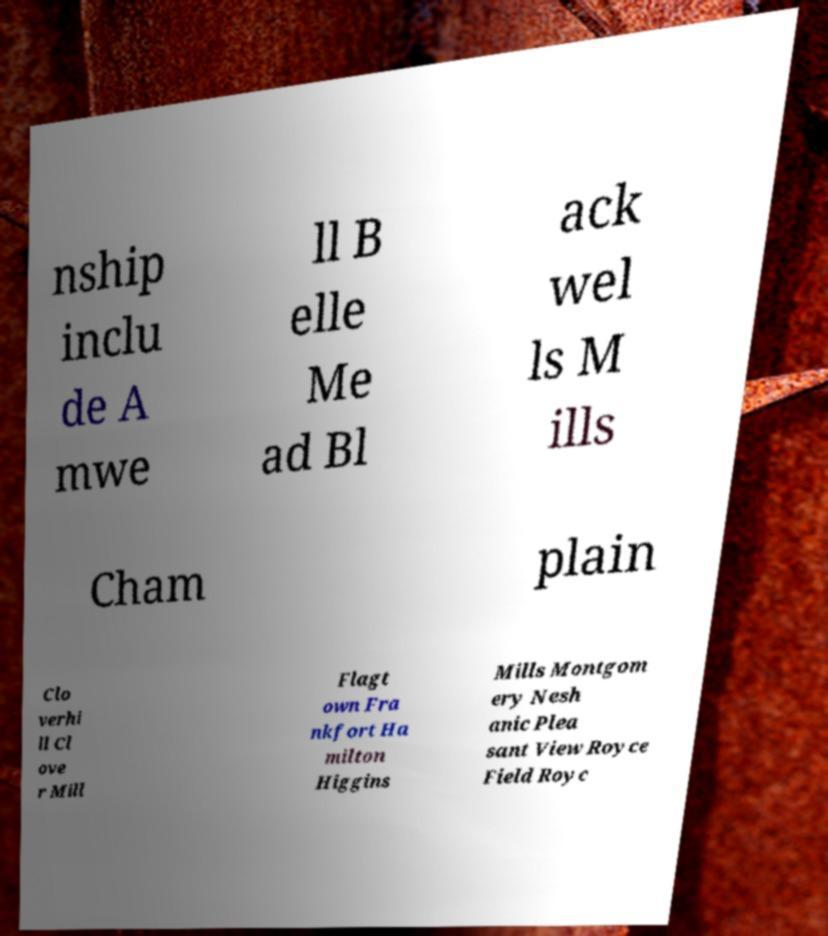Can you accurately transcribe the text from the provided image for me? nship inclu de A mwe ll B elle Me ad Bl ack wel ls M ills Cham plain Clo verhi ll Cl ove r Mill Flagt own Fra nkfort Ha milton Higgins Mills Montgom ery Nesh anic Plea sant View Royce Field Royc 